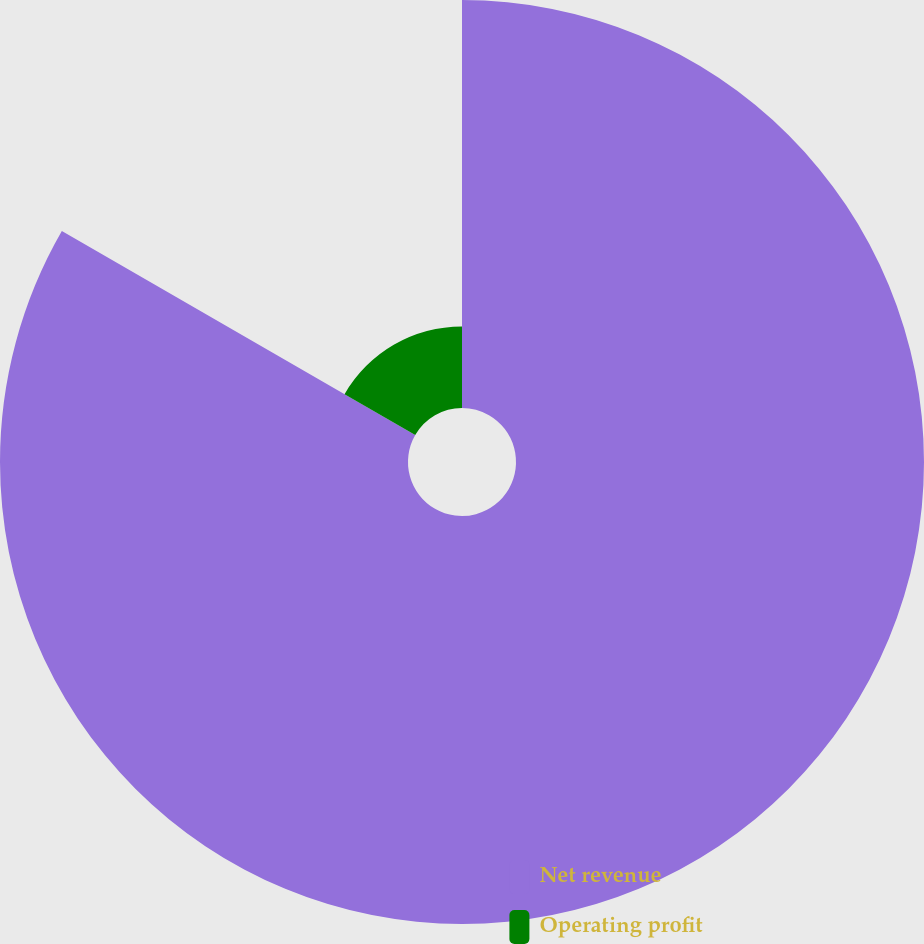Convert chart to OTSL. <chart><loc_0><loc_0><loc_500><loc_500><pie_chart><fcel>Net revenue<fcel>Operating profit<nl><fcel>83.33%<fcel>16.67%<nl></chart> 